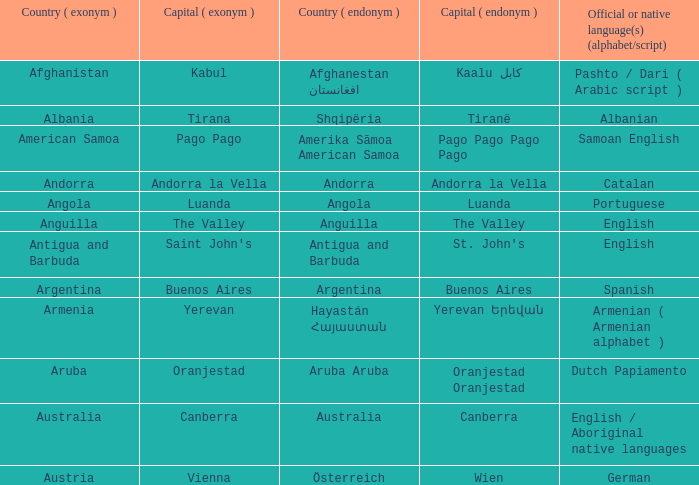What is the regional appellation attributed to the capital of anguilla? The Valley. Parse the table in full. {'header': ['Country ( exonym )', 'Capital ( exonym )', 'Country ( endonym )', 'Capital ( endonym )', 'Official or native language(s) (alphabet/script)'], 'rows': [['Afghanistan', 'Kabul', 'Afghanestan افغانستان', 'Kaalu كابل', 'Pashto / Dari ( Arabic script )'], ['Albania', 'Tirana', 'Shqipëria', 'Tiranë', 'Albanian'], ['American Samoa', 'Pago Pago', 'Amerika Sāmoa American Samoa', 'Pago Pago Pago Pago', 'Samoan English'], ['Andorra', 'Andorra la Vella', 'Andorra', 'Andorra la Vella', 'Catalan'], ['Angola', 'Luanda', 'Angola', 'Luanda', 'Portuguese'], ['Anguilla', 'The Valley', 'Anguilla', 'The Valley', 'English'], ['Antigua and Barbuda', "Saint John's", 'Antigua and Barbuda', "St. John's", 'English'], ['Argentina', 'Buenos Aires', 'Argentina', 'Buenos Aires', 'Spanish'], ['Armenia', 'Yerevan', 'Hayastán Հայաստան', 'Yerevan Երեվան', 'Armenian ( Armenian alphabet )'], ['Aruba', 'Oranjestad', 'Aruba Aruba', 'Oranjestad Oranjestad', 'Dutch Papiamento'], ['Australia', 'Canberra', 'Australia', 'Canberra', 'English / Aboriginal native languages'], ['Austria', 'Vienna', 'Österreich', 'Wien', 'German']]} 